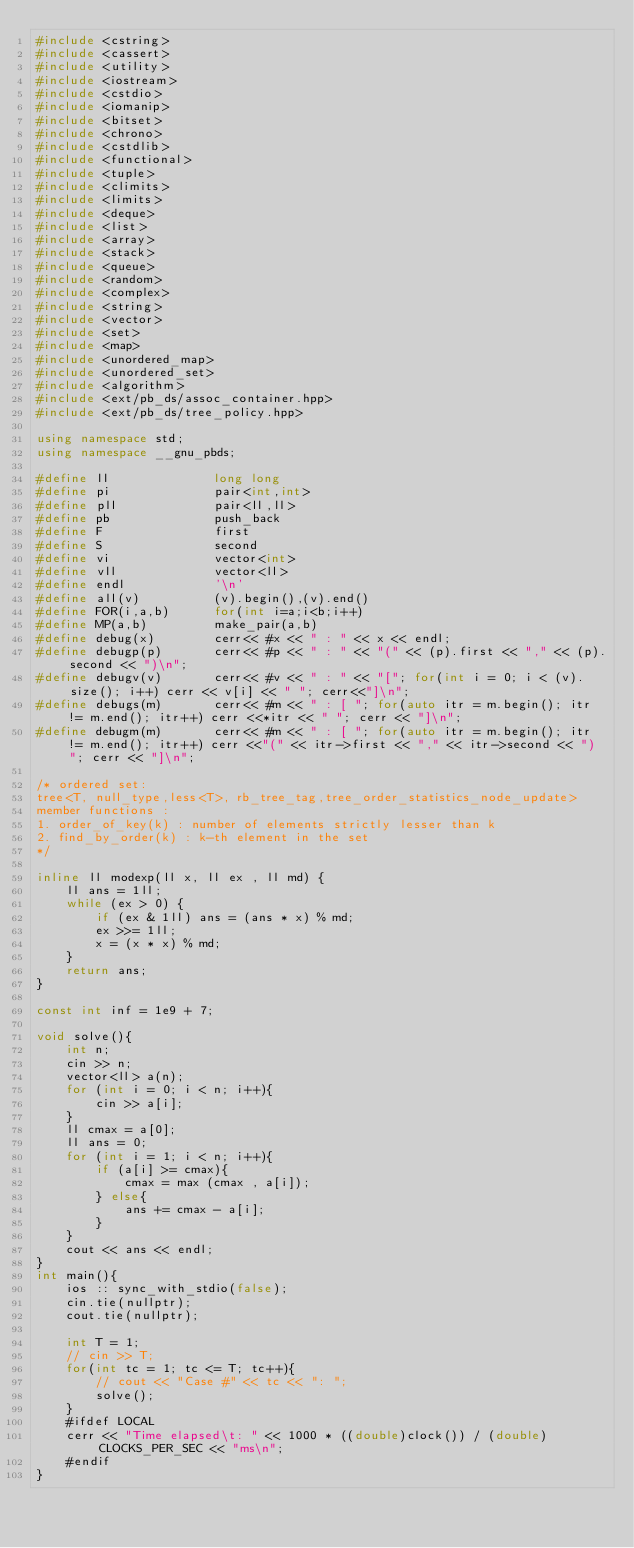<code> <loc_0><loc_0><loc_500><loc_500><_C++_>#include <cstring>
#include <cassert>
#include <utility>
#include <iostream>
#include <cstdio>
#include <iomanip>
#include <bitset>
#include <chrono>
#include <cstdlib>
#include <functional>
#include <tuple>
#include <climits>
#include <limits>
#include <deque>
#include <list>
#include <array>
#include <stack>
#include <queue>
#include <random>
#include <complex>
#include <string>
#include <vector>
#include <set>
#include <map>
#include <unordered_map>
#include <unordered_set>
#include <algorithm>
#include <ext/pb_ds/assoc_container.hpp>
#include <ext/pb_ds/tree_policy.hpp>

using namespace std;
using namespace __gnu_pbds;

#define ll              long long
#define pi              pair<int,int>
#define pll             pair<ll,ll>
#define pb              push_back
#define F               first
#define S               second
#define vi              vector<int>
#define vll             vector<ll>
#define endl            '\n'
#define all(v)          (v).begin(),(v).end()
#define FOR(i,a,b)      for(int i=a;i<b;i++)
#define MP(a,b)         make_pair(a,b)
#define debug(x)        cerr<< #x << " : " << x << endl;
#define debugp(p)       cerr<< #p << " : " << "(" << (p).first << "," << (p).second << ")\n";
#define debugv(v)       cerr<< #v << " : " << "["; for(int i = 0; i < (v).size(); i++) cerr << v[i] << " "; cerr<<"]\n";
#define debugs(m)       cerr<< #m << " : [ "; for(auto itr = m.begin(); itr != m.end(); itr++) cerr <<*itr << " "; cerr << "]\n";
#define debugm(m)       cerr<< #m << " : [ "; for(auto itr = m.begin(); itr != m.end(); itr++) cerr <<"(" << itr->first << "," << itr->second << ") "; cerr << "]\n";

/* ordered set: 
tree<T, null_type,less<T>, rb_tree_tag,tree_order_statistics_node_update>
member functions :
1. order_of_key(k) : number of elements strictly lesser than k
2. find_by_order(k) : k-th element in the set
*/

inline ll modexp(ll x, ll ex , ll md) {
    ll ans = 1ll;
    while (ex > 0) {
        if (ex & 1ll) ans = (ans * x) % md;
        ex >>= 1ll;
        x = (x * x) % md;
    }
    return ans;
}

const int inf = 1e9 + 7;

void solve(){
    int n;
    cin >> n;
    vector<ll> a(n);
    for (int i = 0; i < n; i++){
        cin >> a[i];
    }
    ll cmax = a[0];
    ll ans = 0;
    for (int i = 1; i < n; i++){
        if (a[i] >= cmax){
            cmax = max (cmax , a[i]);
        } else{
            ans += cmax - a[i];
        }
    }
    cout << ans << endl;
}
int main(){
    ios :: sync_with_stdio(false); 
    cin.tie(nullptr); 
    cout.tie(nullptr);
    
    int T = 1;
    // cin >> T;
    for(int tc = 1; tc <= T; tc++){
        // cout << "Case #" << tc << ": ";
        solve();
    }
    #ifdef LOCAL
    cerr << "Time elapsed\t: " << 1000 * ((double)clock()) / (double)CLOCKS_PER_SEC << "ms\n";       
    #endif
}

</code> 